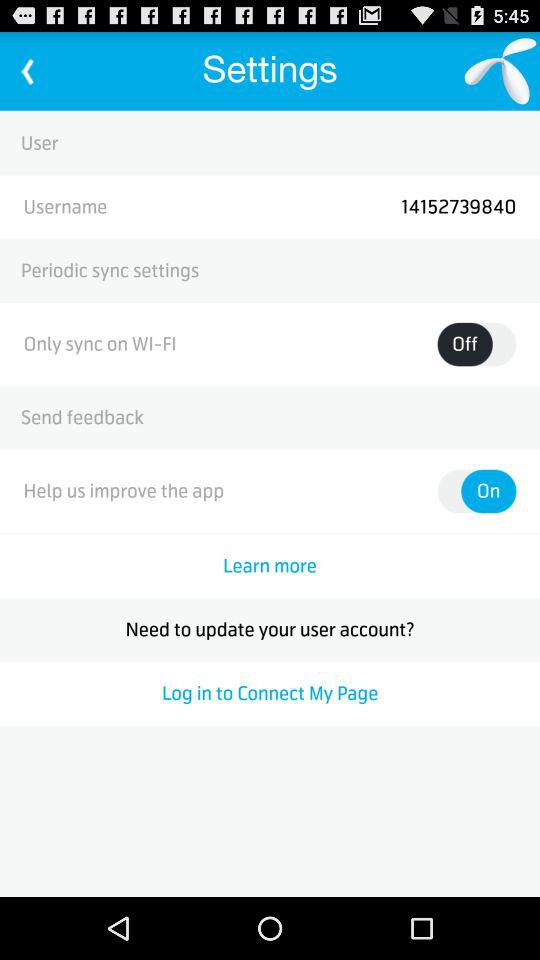What is the username? The username is "14152739840". 